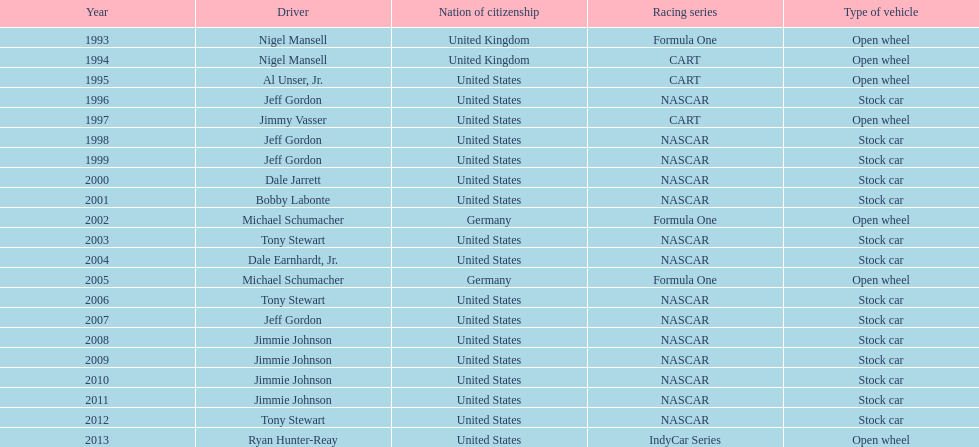Which racer achieved four back-to-back victories? Jimmie Johnson. 